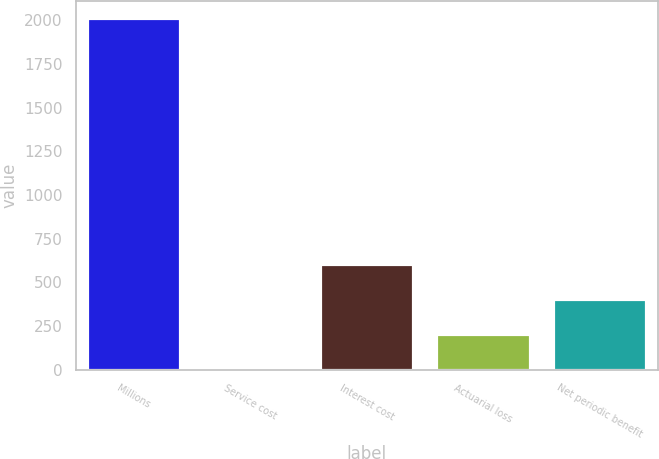Convert chart. <chart><loc_0><loc_0><loc_500><loc_500><bar_chart><fcel>Millions<fcel>Service cost<fcel>Interest cost<fcel>Actuarial loss<fcel>Net periodic benefit<nl><fcel>2012<fcel>3<fcel>605.7<fcel>203.9<fcel>404.8<nl></chart> 